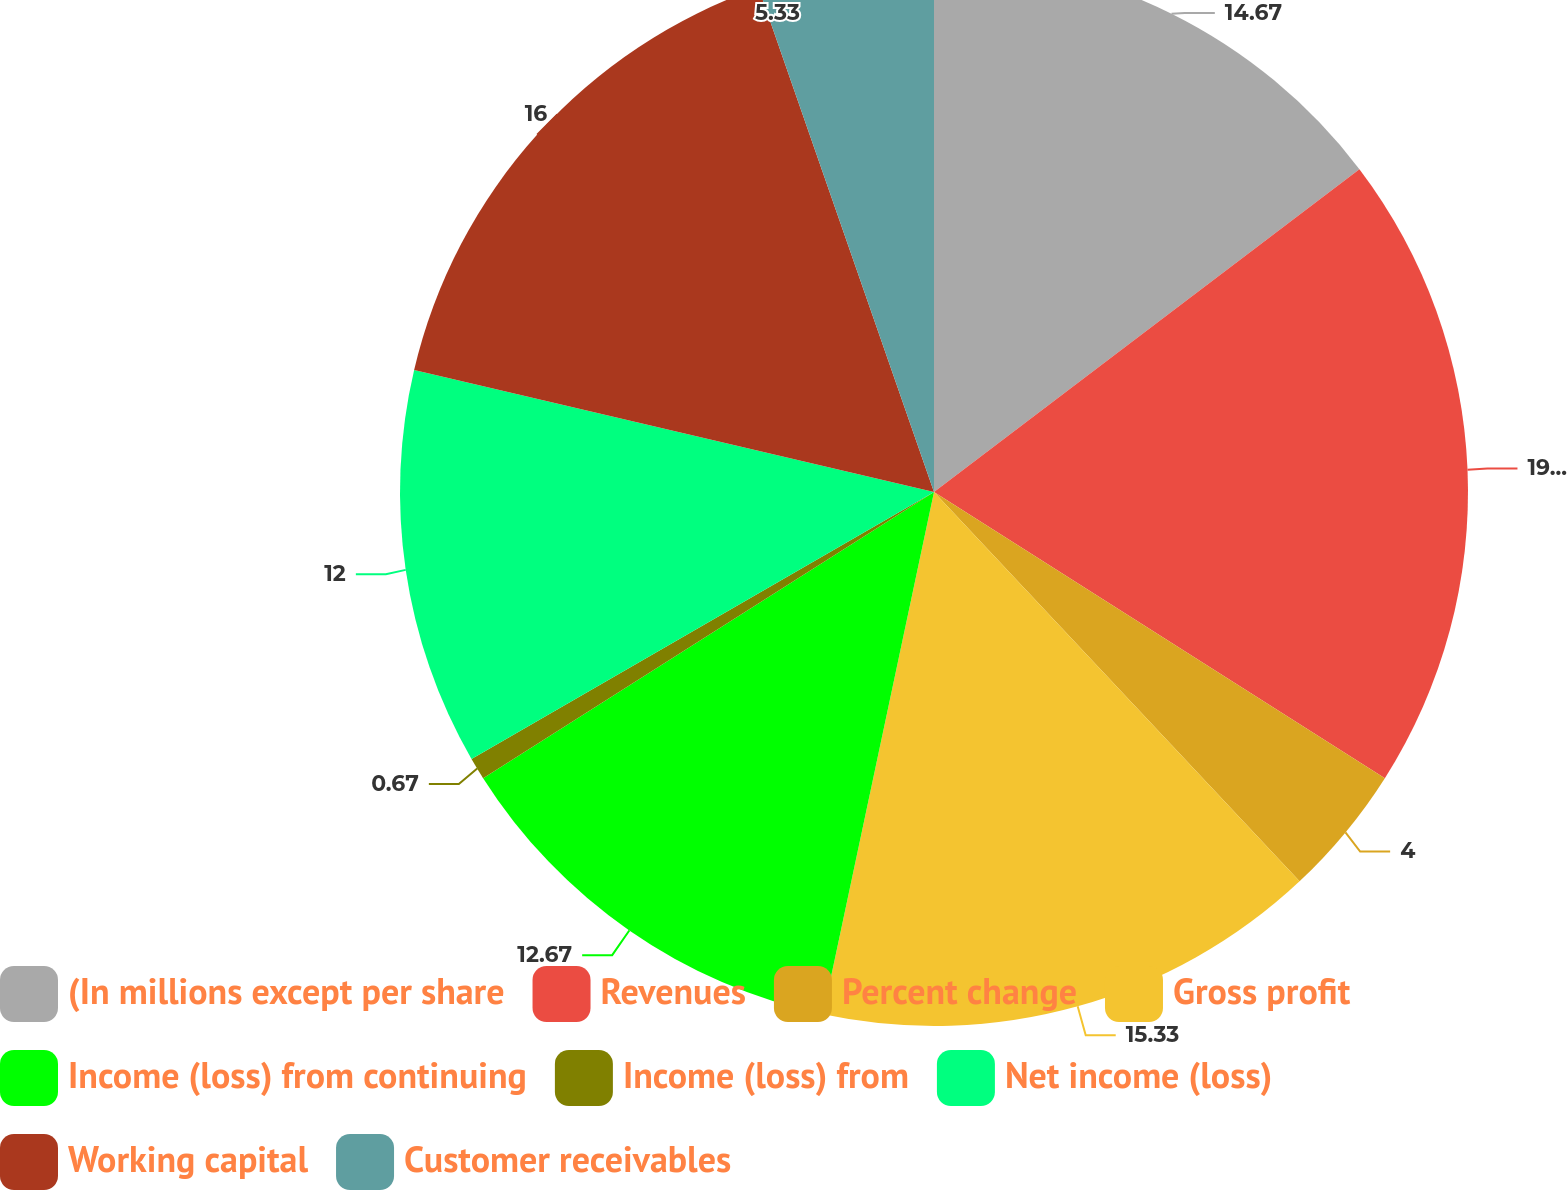Convert chart to OTSL. <chart><loc_0><loc_0><loc_500><loc_500><pie_chart><fcel>(In millions except per share<fcel>Revenues<fcel>Percent change<fcel>Gross profit<fcel>Income (loss) from continuing<fcel>Income (loss) from<fcel>Net income (loss)<fcel>Working capital<fcel>Customer receivables<nl><fcel>14.67%<fcel>19.33%<fcel>4.0%<fcel>15.33%<fcel>12.67%<fcel>0.67%<fcel>12.0%<fcel>16.0%<fcel>5.33%<nl></chart> 